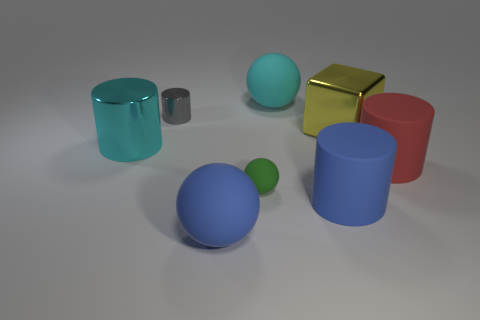What material is the big thing that is the same color as the large metal cylinder?
Your response must be concise. Rubber. Is the number of blue matte balls greater than the number of cyan objects?
Your answer should be compact. No. What is the material of the cube?
Offer a very short reply. Metal. There is a cylinder on the right side of the shiny cube; does it have the same size as the cyan ball?
Provide a short and direct response. Yes. There is a metallic object right of the cyan matte object; what size is it?
Your answer should be very brief. Large. Is there anything else that is made of the same material as the large block?
Your answer should be very brief. Yes. What number of large red objects are there?
Provide a succinct answer. 1. Does the tiny metal object have the same color as the cube?
Give a very brief answer. No. The large matte object that is both to the left of the blue cylinder and in front of the small metallic cylinder is what color?
Your answer should be very brief. Blue. There is a large cyan cylinder; are there any large cyan shiny things left of it?
Keep it short and to the point. No. 